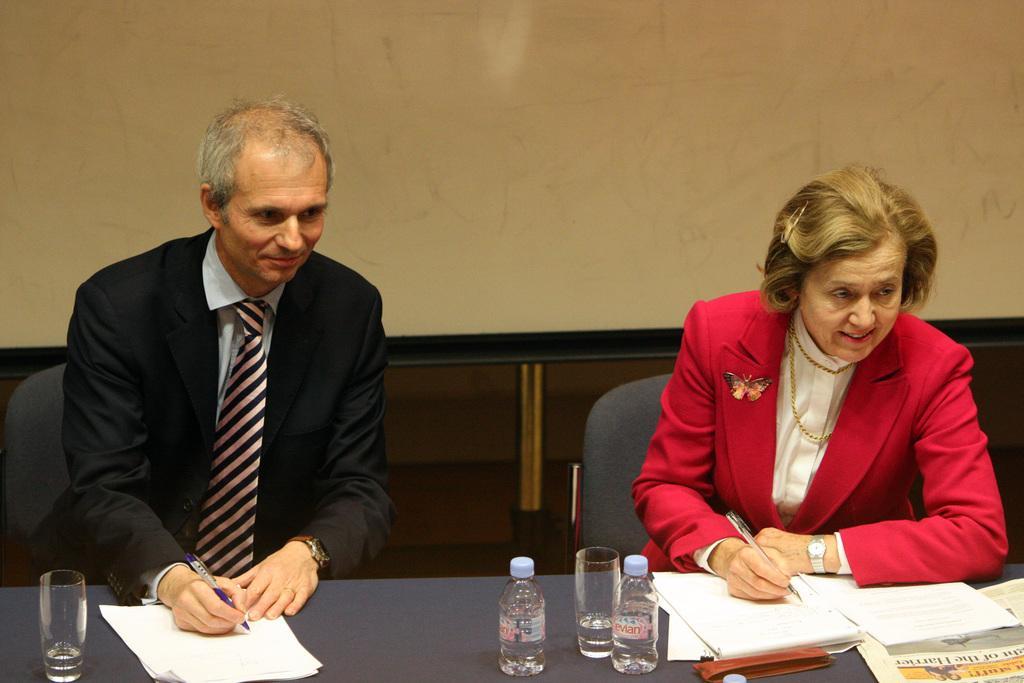Please provide a concise description of this image. There are two persons sitting in chairs and writing on a paper which is on the table and the table consists of two water bottles,glasses and a news paper. 